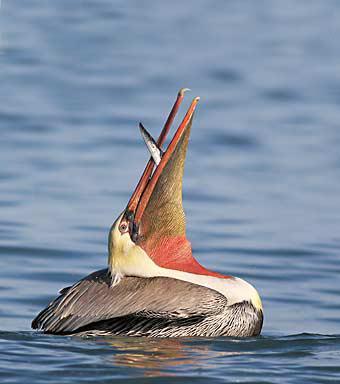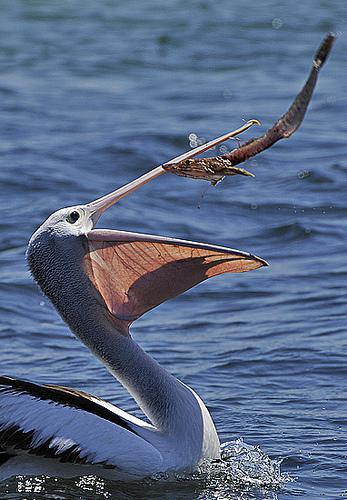The first image is the image on the left, the second image is the image on the right. Assess this claim about the two images: "Each image shows a single pelican floating on water, and at least one image shows a fish in the bird's bill.". Correct or not? Answer yes or no. Yes. The first image is the image on the left, the second image is the image on the right. For the images shown, is this caption "There is one human interacting with at least one bird in the left image." true? Answer yes or no. No. 